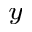Convert formula to latex. <formula><loc_0><loc_0><loc_500><loc_500>_ { y }</formula> 